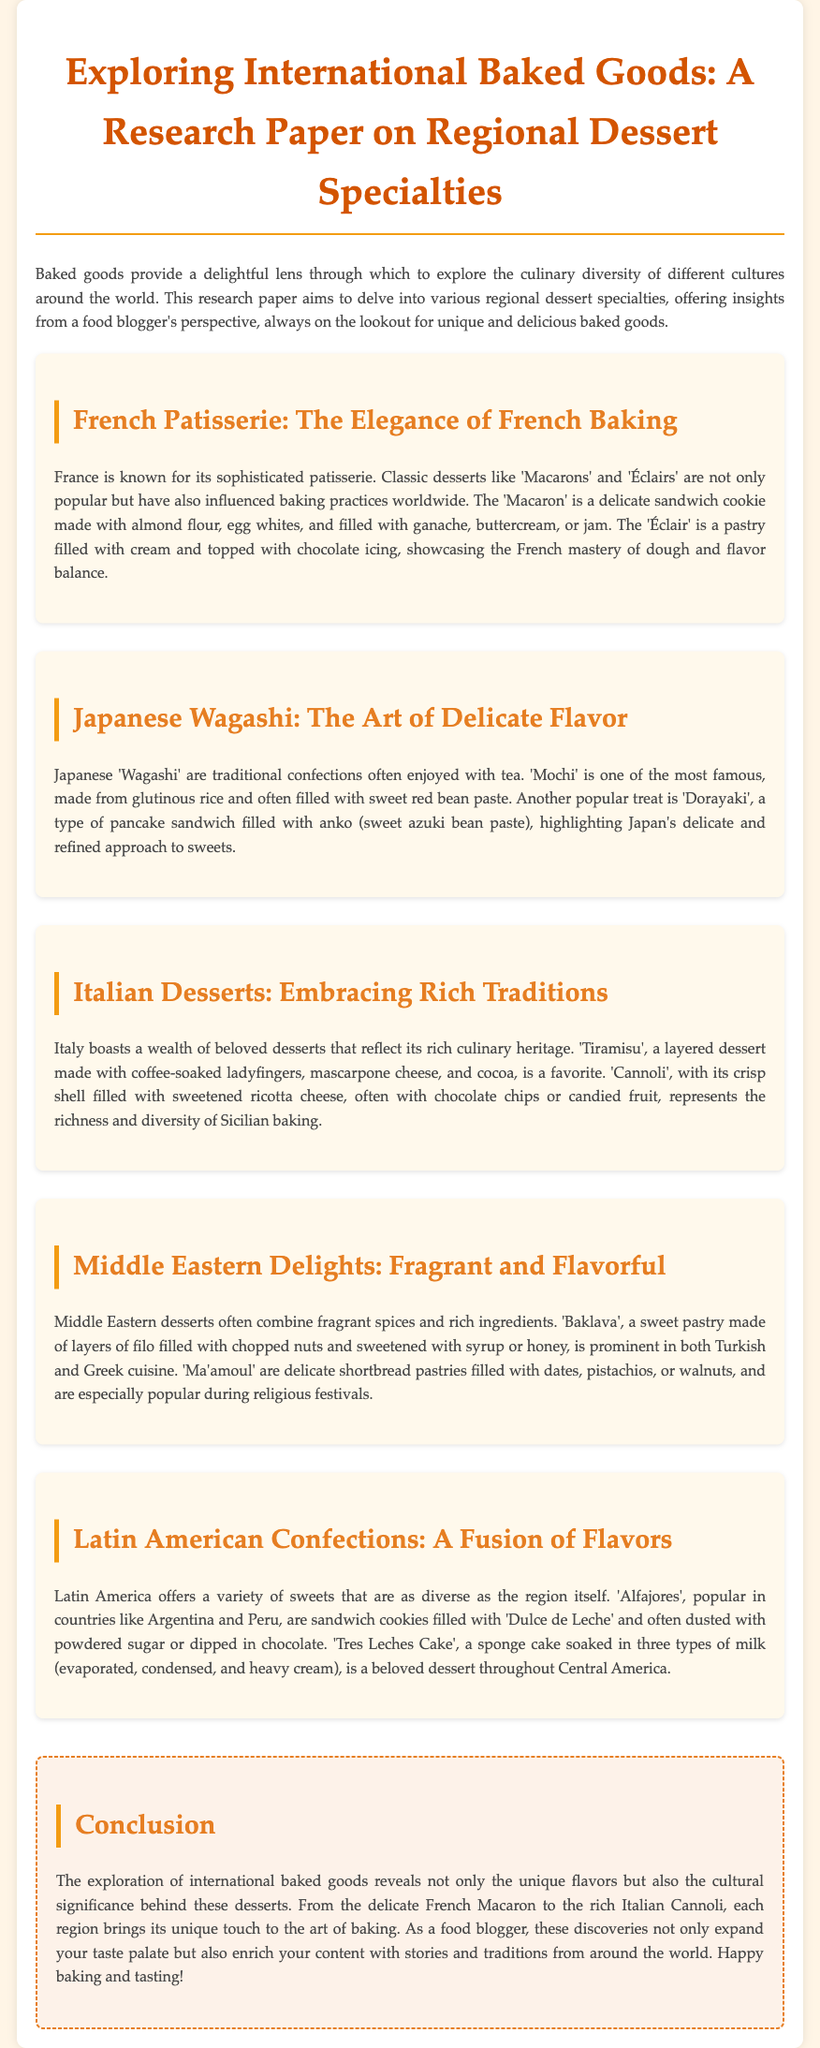What is the main focus of the research paper? The main focus of the research paper is to explore various regional dessert specialties and their cultural significance.
Answer: regional dessert specialties Which French dessert is described as a delicate sandwich cookie? The document specifically describes 'Macarons' as a delicate sandwich cookie made with almond flour.
Answer: Macarons What traditional Japanese confection is made from glutinous rice? The document mentions 'Mochi' as a traditional Japanese confection made from glutinous rice.
Answer: Mochi What Italian dessert incorporates coffee-soaked ladyfingers? 'Tiramisu' is the Italian dessert mentioned that is made with coffee-soaked ladyfingers.
Answer: Tiramisu Which Middle Eastern dessert is made of layers of filo filled with nuts? The dessert described is 'Baklava', which is made of layers of filo filled with chopped nuts.
Answer: Baklava Why are 'Alfajores' popular in Latin America? 'Alfajores' are popular because they are sandwich cookies filled with 'Dulce de Leche'.
Answer: 'Dulce de Leche' What baking tradition is highlighted in the section on French Patisserie? The baking tradition highlighted in this section is the sophistication of French baking.
Answer: sophistication of French baking Which region is associated with 'Ma'amoul' pastries? 'Ma'amoul' pastries are especially popular in the Middle East.
Answer: Middle East What is a key characteristic of Japanese 'Wagashi'? A key characteristic of Japanese 'Wagashi' is their delicate flavors, often enjoyed with tea.
Answer: delicate flavors 